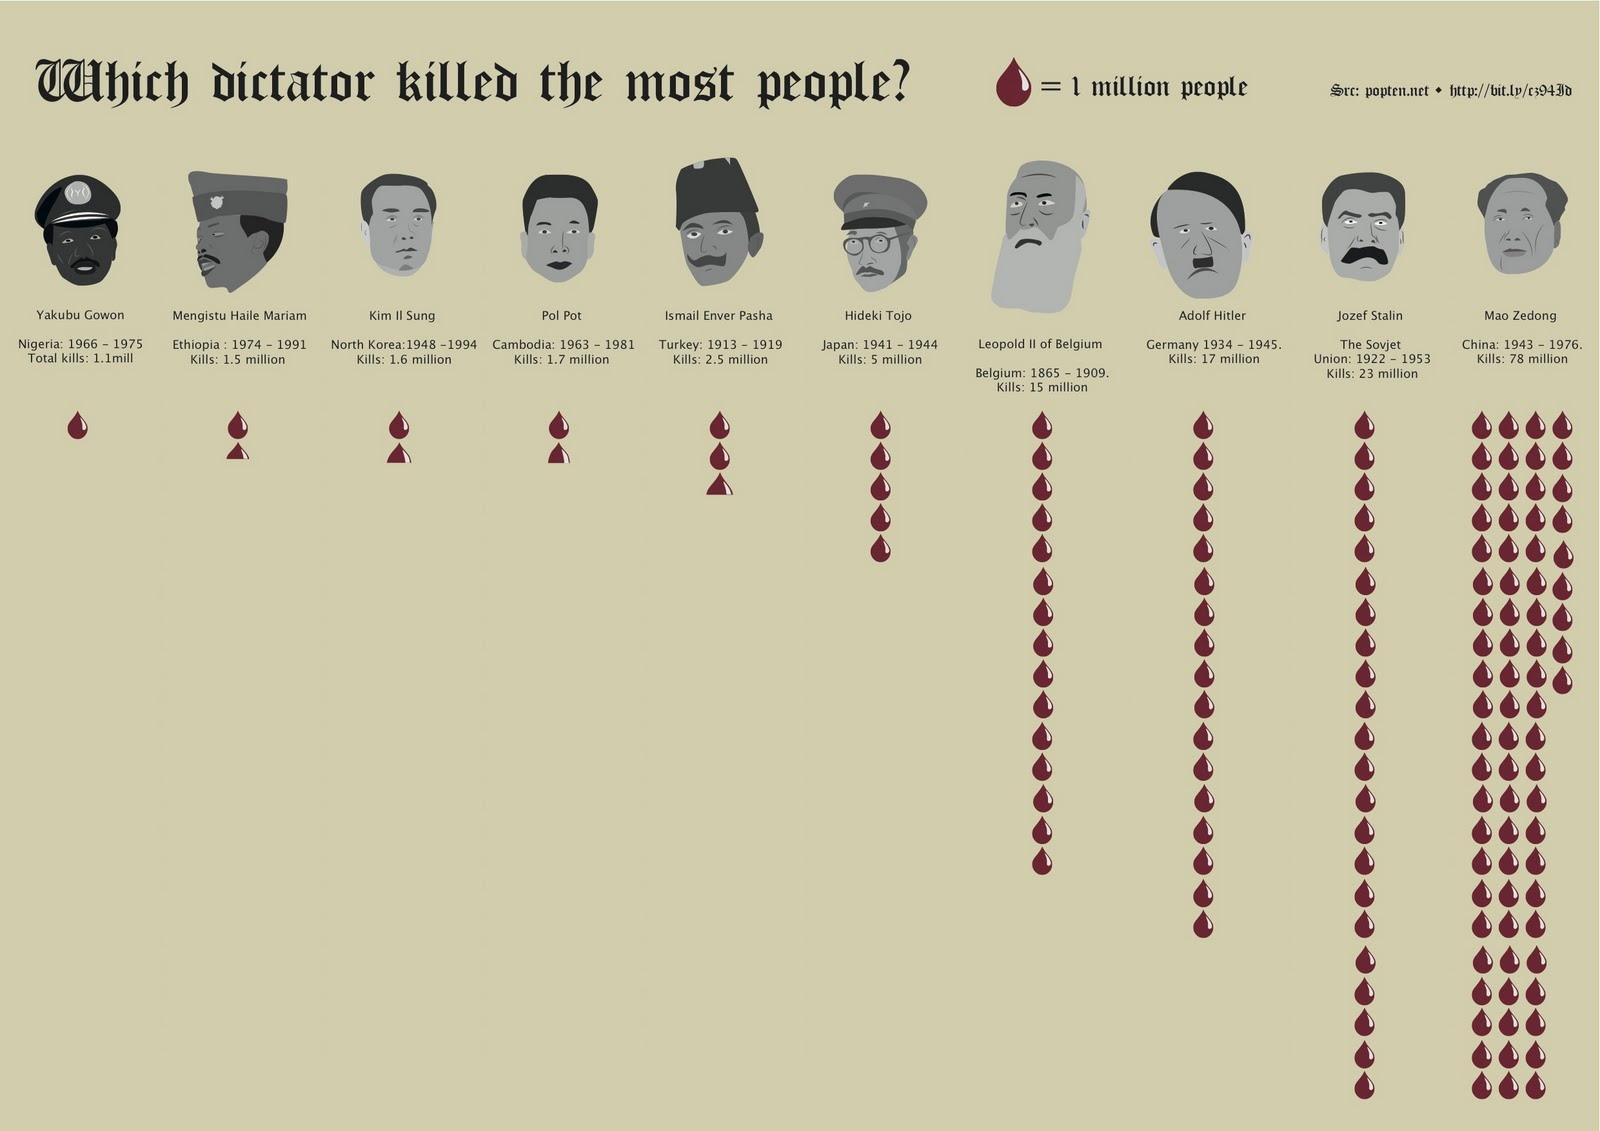List a handful of essential elements in this visual. Mao Zedong killed 78 million people over a period of 33 years. The Soviet Union had the second largest number of killings. Ismail Enver Pasha was responsible for the killing of 2.5 million people. Adolf Hitler is believed to have killed 17 million people during his regime. Hideki Tojo, a Japanese person, was from Japan. 